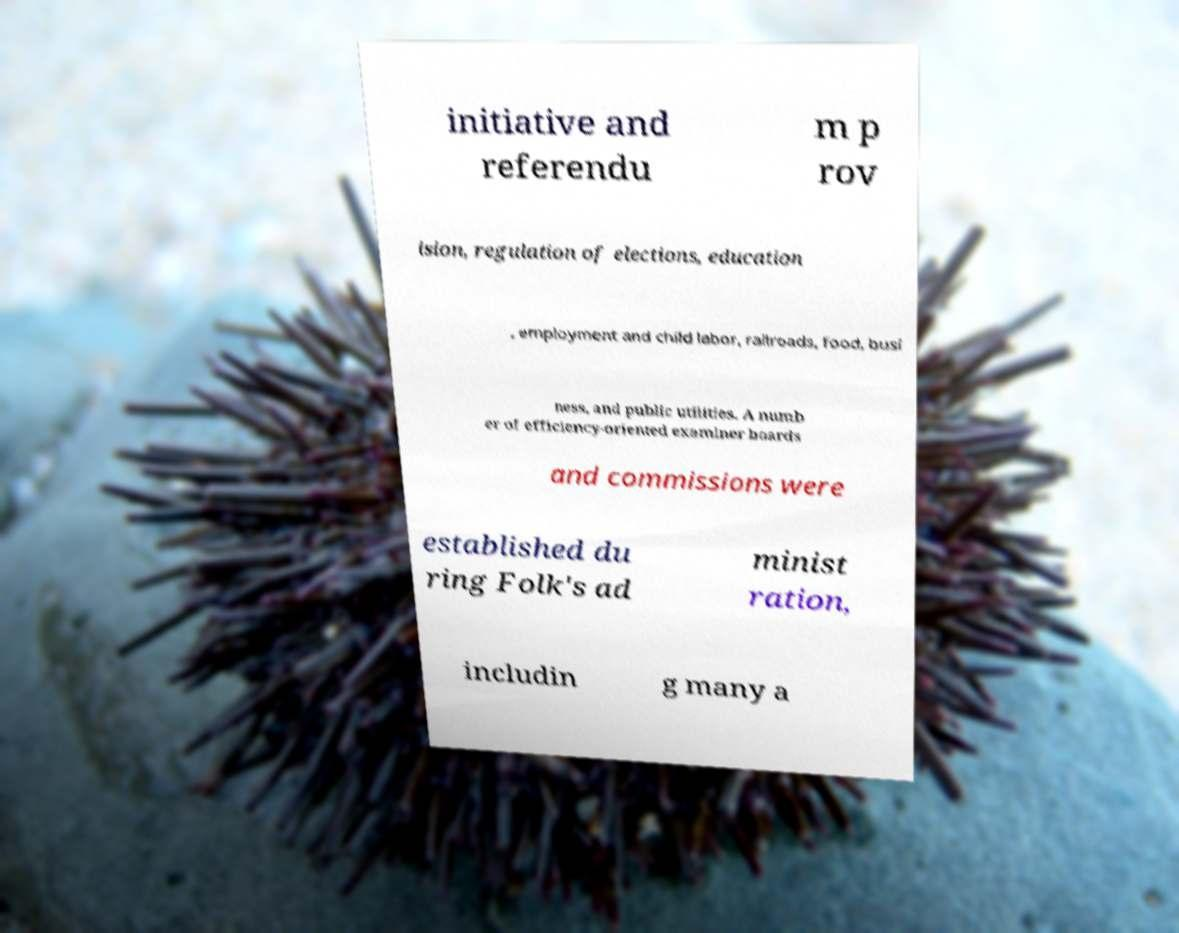I need the written content from this picture converted into text. Can you do that? initiative and referendu m p rov ision, regulation of elections, education , employment and child labor, railroads, food, busi ness, and public utilities. A numb er of efficiency-oriented examiner boards and commissions were established du ring Folk's ad minist ration, includin g many a 